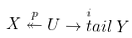Convert formula to latex. <formula><loc_0><loc_0><loc_500><loc_500>X \stackrel { p } { \twoheadleftarrow } U \stackrel { i } { \rightarrow t a i l } Y</formula> 